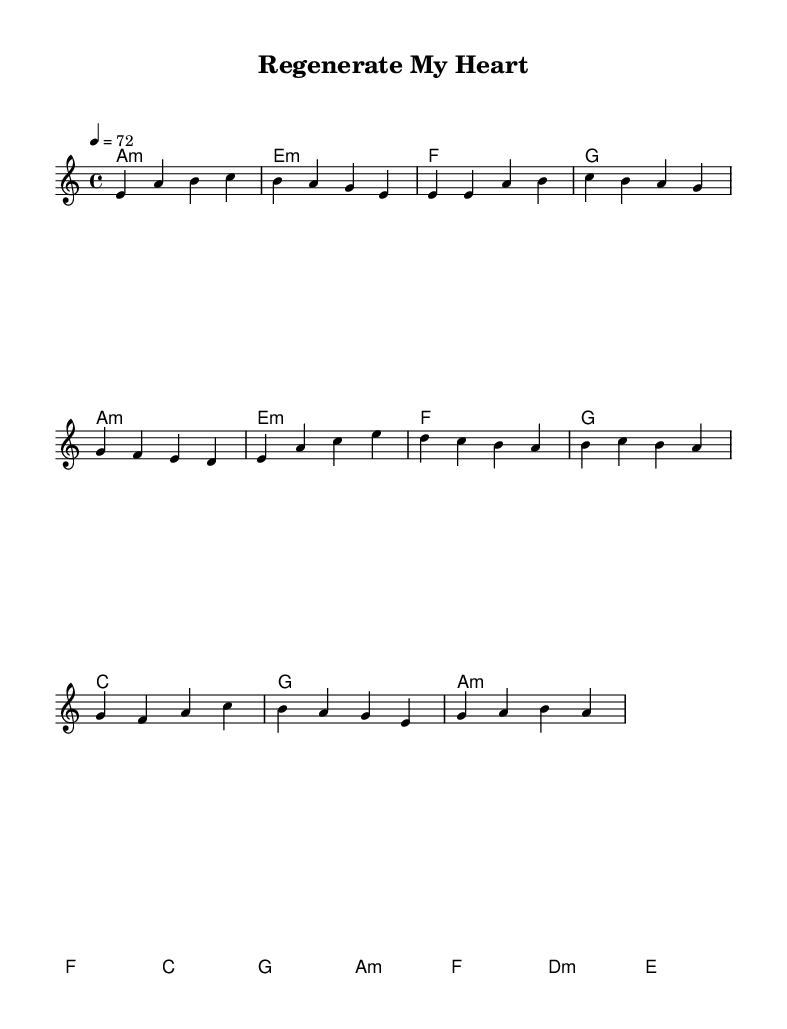What is the key signature of this music? The key signature shows one flat, indicating the key is A minor. A minor is related to C major, which contains no sharps or flats and uses the same key signature.
Answer: A minor What is the time signature of this music? The time signature is indicated at the beginning of the score as 4/4, which means there are four beats in each measure and the quarter note receives one beat.
Answer: 4/4 What is the tempo marking for this piece? The tempo marking is located at the beginning and is marked as 4 = 72, which means the quarter note should be played at a speed of 72 beats per minute.
Answer: 72 How many measures are in the chorus? To find this, count the measures in the chorus section, which starts after the verse. The chorus has 8 measures in total.
Answer: 8 Which chords are used in the verse after the first measure? The verse starts with the chord A minor in the first measure, and after that, the chords used are E minor, F, G, C, G, and A minor. This sequence indicates the progression through the verse section.
Answer: E minor, F, G, C, G, A minor What is the main theme of the lyrics related to the song’s title? The song title "Regenerate My Heart" suggests a focus on themes of renewal or healing. Typically, K-Pop ballads express deep emotions, often relating to love, loss, and recovery, possibly referencing the regenerative abilities of flatworms as a metaphor.
Answer: Renewal 